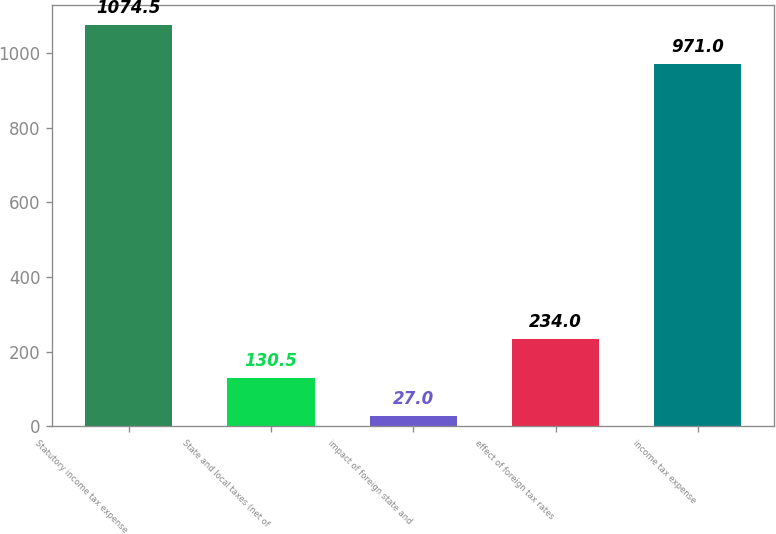<chart> <loc_0><loc_0><loc_500><loc_500><bar_chart><fcel>Statutory income tax expense<fcel>State and local taxes (net of<fcel>impact of foreign state and<fcel>effect of foreign tax rates<fcel>income tax expense<nl><fcel>1074.5<fcel>130.5<fcel>27<fcel>234<fcel>971<nl></chart> 